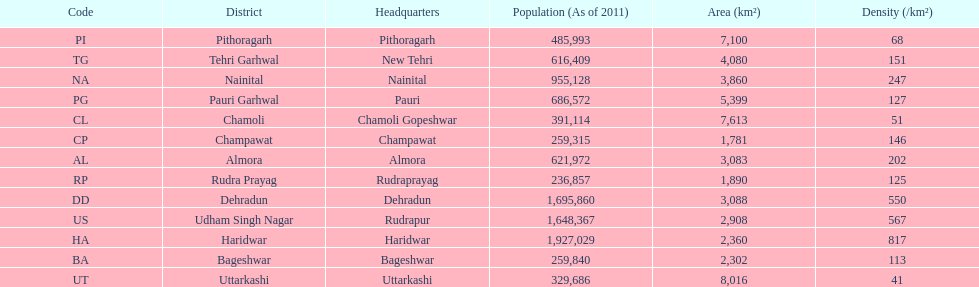Which headquarter has the same district name but has a density of 202? Almora. 